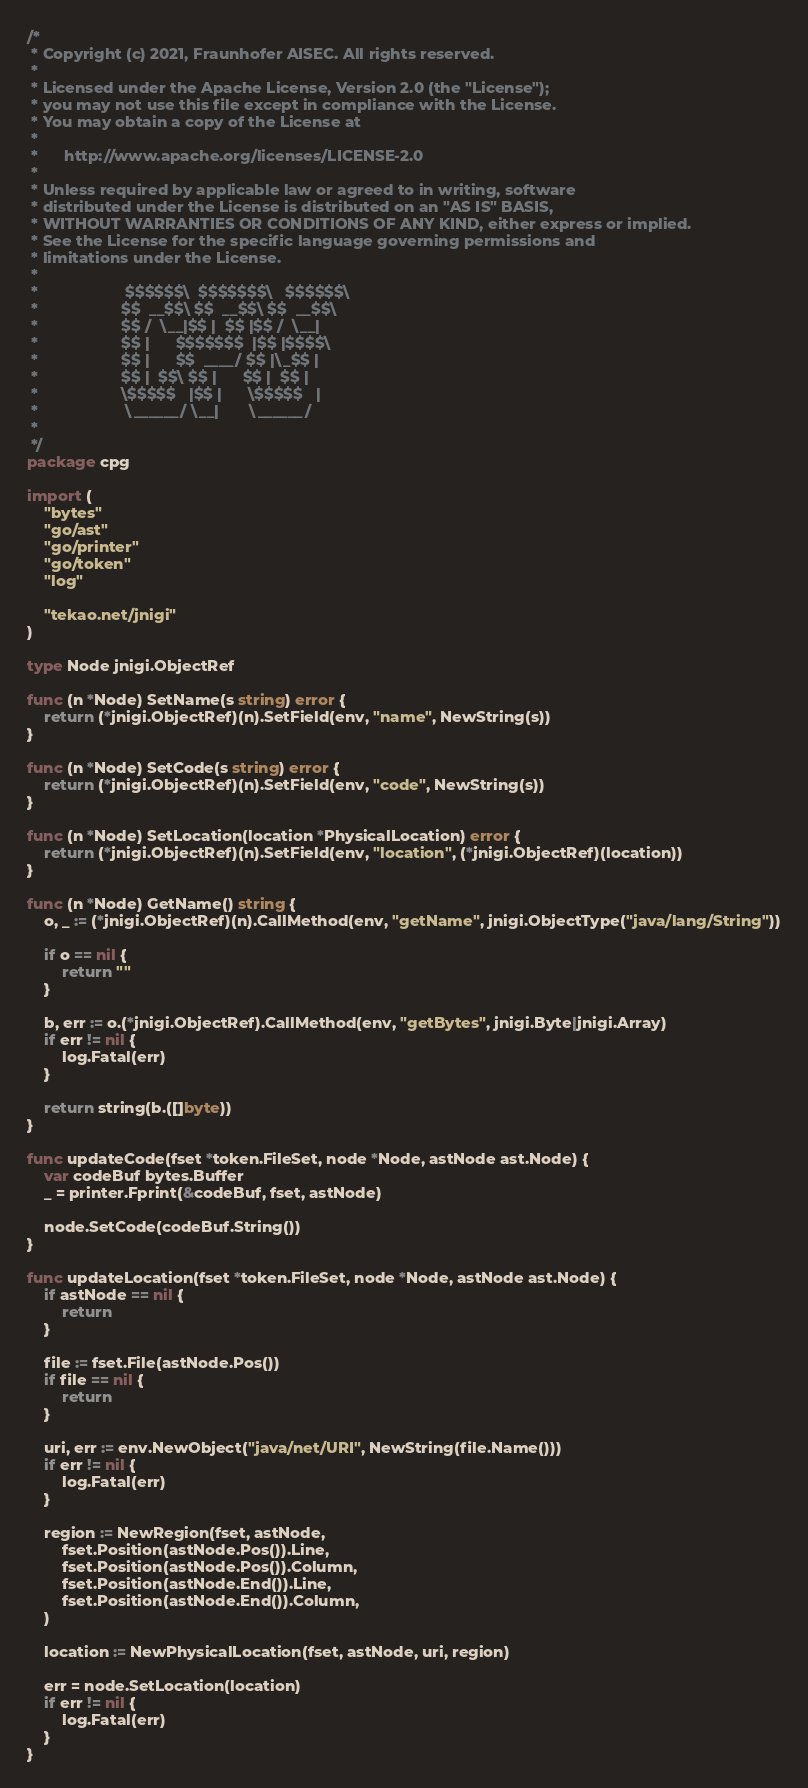Convert code to text. <code><loc_0><loc_0><loc_500><loc_500><_Go_>/*
 * Copyright (c) 2021, Fraunhofer AISEC. All rights reserved.
 *
 * Licensed under the Apache License, Version 2.0 (the "License");
 * you may not use this file except in compliance with the License.
 * You may obtain a copy of the License at
 *
 *      http://www.apache.org/licenses/LICENSE-2.0
 *
 * Unless required by applicable law or agreed to in writing, software
 * distributed under the License is distributed on an "AS IS" BASIS,
 * WITHOUT WARRANTIES OR CONDITIONS OF ANY KIND, either express or implied.
 * See the License for the specific language governing permissions and
 * limitations under the License.
 *
 *                    $$$$$$\  $$$$$$$\   $$$$$$\
 *                   $$  __$$\ $$  __$$\ $$  __$$\
 *                   $$ /  \__|$$ |  $$ |$$ /  \__|
 *                   $$ |      $$$$$$$  |$$ |$$$$\
 *                   $$ |      $$  ____/ $$ |\_$$ |
 *                   $$ |  $$\ $$ |      $$ |  $$ |
 *                   \$$$$$   |$$ |      \$$$$$   |
 *                    \______/ \__|       \______/
 *
 */
package cpg

import (
	"bytes"
	"go/ast"
	"go/printer"
	"go/token"
	"log"

	"tekao.net/jnigi"
)

type Node jnigi.ObjectRef

func (n *Node) SetName(s string) error {
	return (*jnigi.ObjectRef)(n).SetField(env, "name", NewString(s))
}

func (n *Node) SetCode(s string) error {
	return (*jnigi.ObjectRef)(n).SetField(env, "code", NewString(s))
}

func (n *Node) SetLocation(location *PhysicalLocation) error {
	return (*jnigi.ObjectRef)(n).SetField(env, "location", (*jnigi.ObjectRef)(location))
}

func (n *Node) GetName() string {
	o, _ := (*jnigi.ObjectRef)(n).CallMethod(env, "getName", jnigi.ObjectType("java/lang/String"))

	if o == nil {
		return ""
	}

	b, err := o.(*jnigi.ObjectRef).CallMethod(env, "getBytes", jnigi.Byte|jnigi.Array)
	if err != nil {
		log.Fatal(err)
	}

	return string(b.([]byte))
}

func updateCode(fset *token.FileSet, node *Node, astNode ast.Node) {
	var codeBuf bytes.Buffer
	_ = printer.Fprint(&codeBuf, fset, astNode)

	node.SetCode(codeBuf.String())
}

func updateLocation(fset *token.FileSet, node *Node, astNode ast.Node) {
	if astNode == nil {
		return
	}

	file := fset.File(astNode.Pos())
	if file == nil {
		return
	}

	uri, err := env.NewObject("java/net/URI", NewString(file.Name()))
	if err != nil {
		log.Fatal(err)
	}

	region := NewRegion(fset, astNode,
		fset.Position(astNode.Pos()).Line,
		fset.Position(astNode.Pos()).Column,
		fset.Position(astNode.End()).Line,
		fset.Position(astNode.End()).Column,
	)

	location := NewPhysicalLocation(fset, astNode, uri, region)

	err = node.SetLocation(location)
	if err != nil {
		log.Fatal(err)
	}
}
</code> 